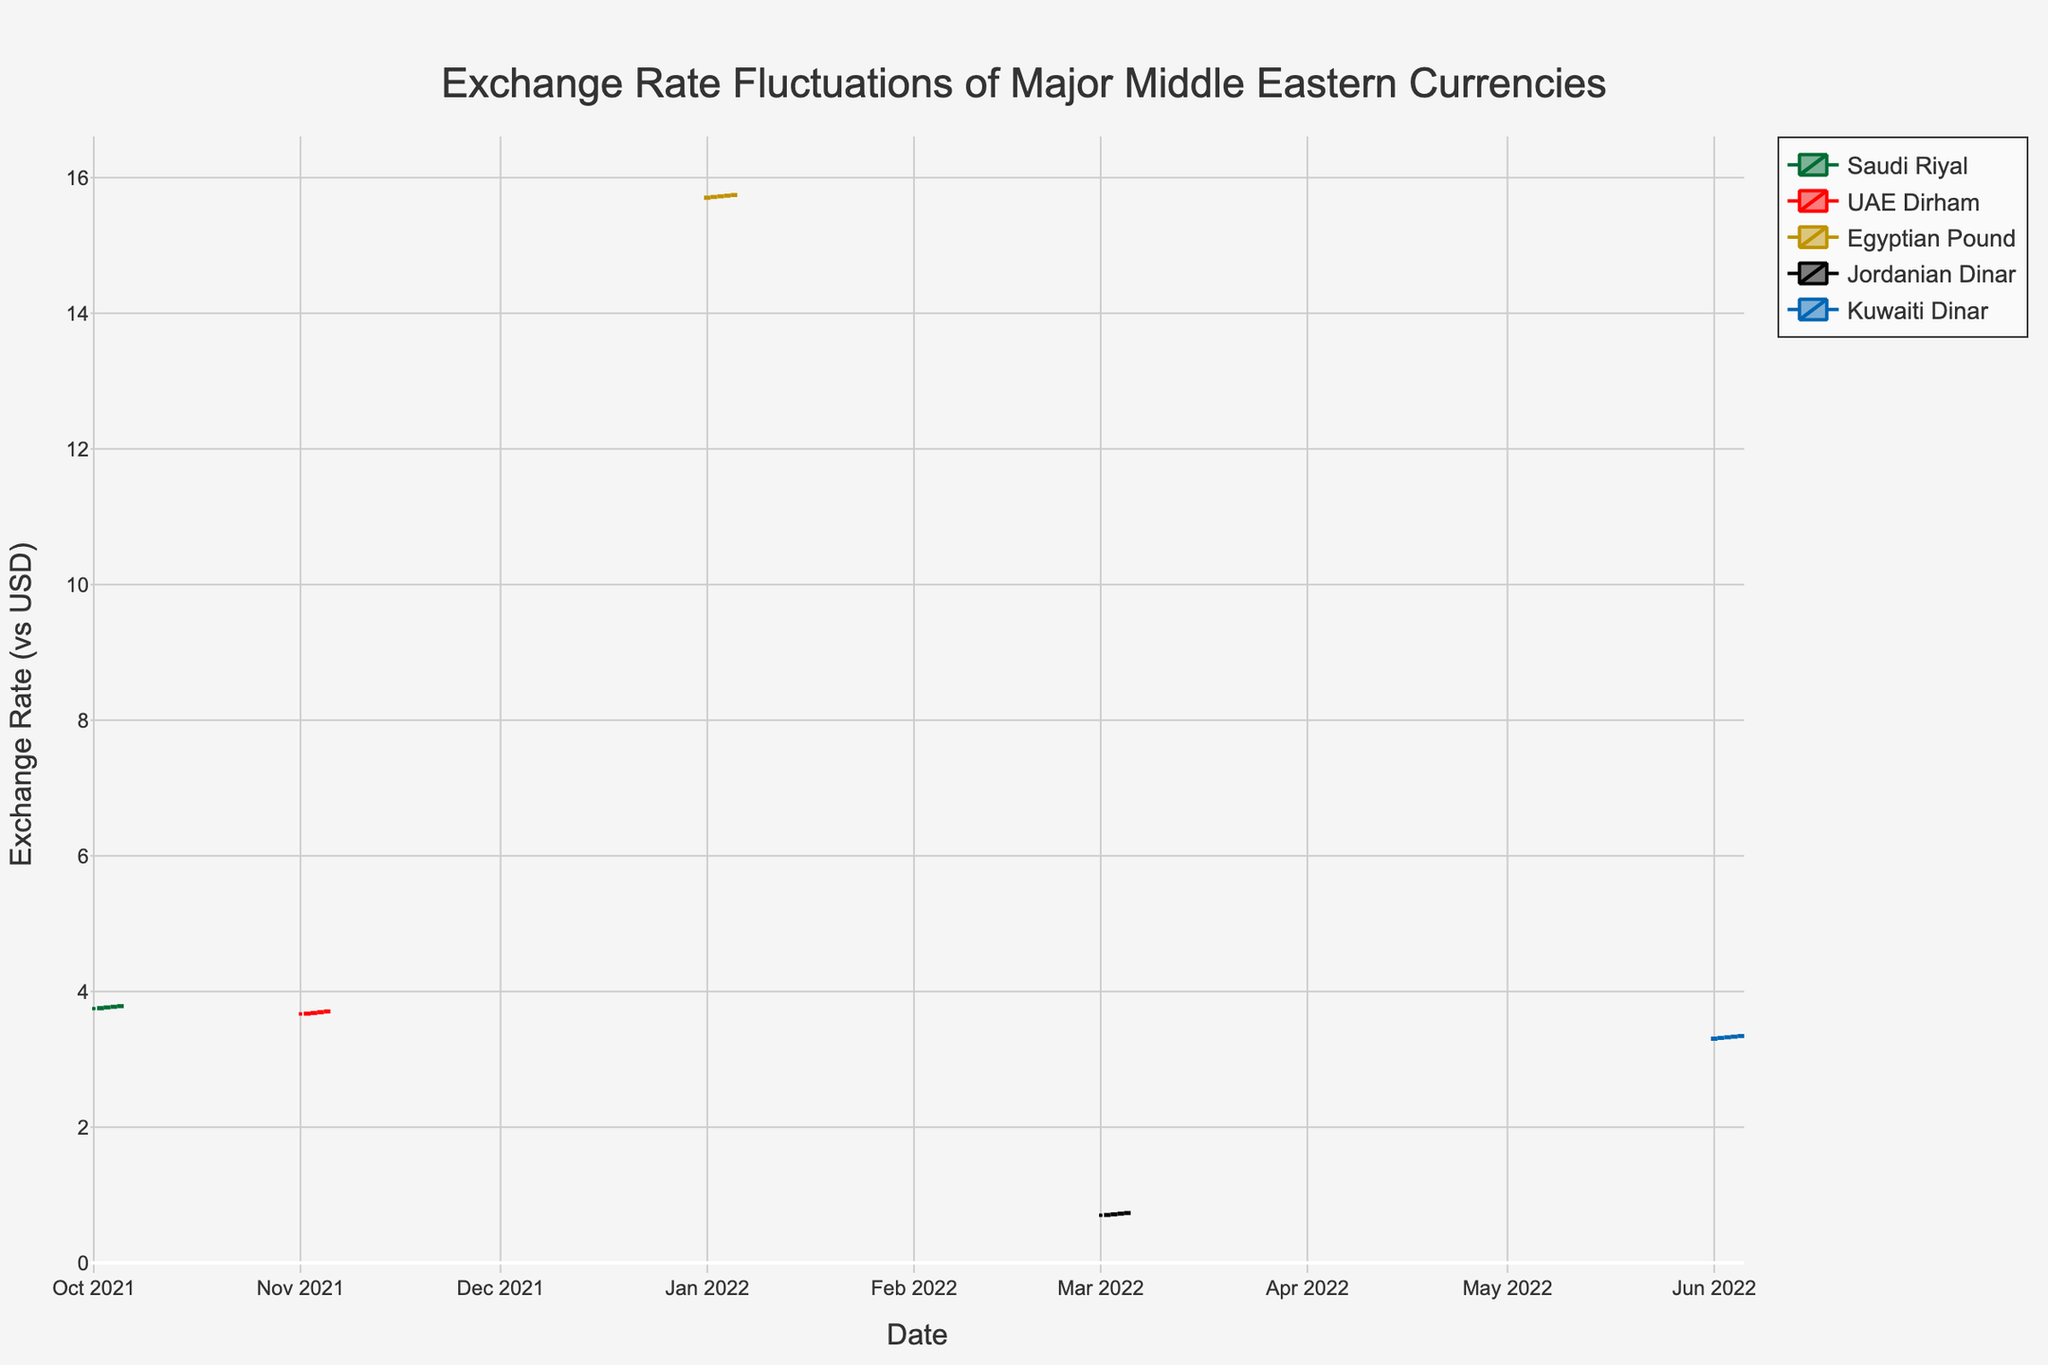How many currencies are tracked in this plot? Observe the legend; it lists five different currencies tracked in the plot: Saudi Riyal, UAE Dirham, Egyptian Pound, Jordanian Dinar, and Kuwaiti Dinar.
Answer: 5 What is the highest exchange rate value recorded for the Kuwaiti Dinar? Look at the candlesticks corresponding to the Kuwaiti Dinar, and identify the highest 'High' value, which is 3.36.
Answer: 3.36 Which currency shows the most significant daily fluctuation in this plot? Compare the length of the wicks (lines at the top and bottom of the candlestick) of the different currencies. The Kuwaiti Dinar has the longest wicks which indicate the largest daily fluctuations.
Answer: Kuwaiti Dinar On 2022-03-04, did the Jordanian Dinar close higher or lower than it opened? Check the candlestick for 2022-03-04 for the Jordanian Dinar. The close value (0.73) is higher than the open value (0.72).
Answer: Higher What were the open and close values for the Egyptian Pound on 2022-01-03? Look for the candlestick corresponding to 2022-01-03 for the Egyptian Pound. The 'Open' value is 15.72 and the 'Close' value is 15.73.
Answer: Open: 15.72, Close: 15.73 Which currency had the highest average exchange rate over the given period? Calculate the average exchange rate for each currency by averaging their opening, high, low, and closing values, and compare. The Kuwaiti Dinar shows higher average exchange rates overall compared to the other currencies.
Answer: Kuwaiti Dinar What is the trend of the UAE Dirham's exchange rate from 2021-11-01 to 2021-11-05? Observe the candlesticks for UAE Dirham in the specified range. The 'Close' value increases each day from 3.67 on 2021-11-01 to 3.71 on 2021-11-05, indicating an upward trend.
Answer: Upward trend Which currency has the smallest range between its highest and lowest recorded values? Calculate the range (High - Low) for each currency and compare. The Jordanian Dinar, with a range of 0.06 (0.75 - 0.69), has the smallest range.
Answer: Jordanian Dinar 